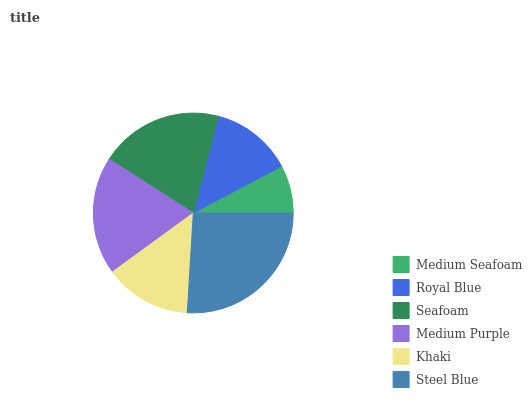Is Medium Seafoam the minimum?
Answer yes or no. Yes. Is Steel Blue the maximum?
Answer yes or no. Yes. Is Royal Blue the minimum?
Answer yes or no. No. Is Royal Blue the maximum?
Answer yes or no. No. Is Royal Blue greater than Medium Seafoam?
Answer yes or no. Yes. Is Medium Seafoam less than Royal Blue?
Answer yes or no. Yes. Is Medium Seafoam greater than Royal Blue?
Answer yes or no. No. Is Royal Blue less than Medium Seafoam?
Answer yes or no. No. Is Medium Purple the high median?
Answer yes or no. Yes. Is Khaki the low median?
Answer yes or no. Yes. Is Medium Seafoam the high median?
Answer yes or no. No. Is Medium Seafoam the low median?
Answer yes or no. No. 